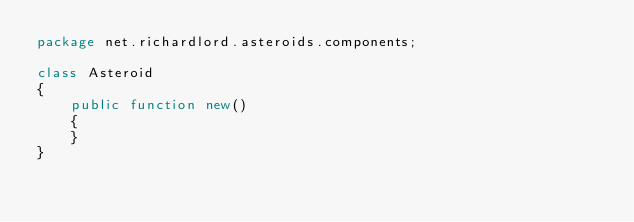<code> <loc_0><loc_0><loc_500><loc_500><_Haxe_>package net.richardlord.asteroids.components;

class Asteroid
{
    public function new()
    {
    }
}
</code> 